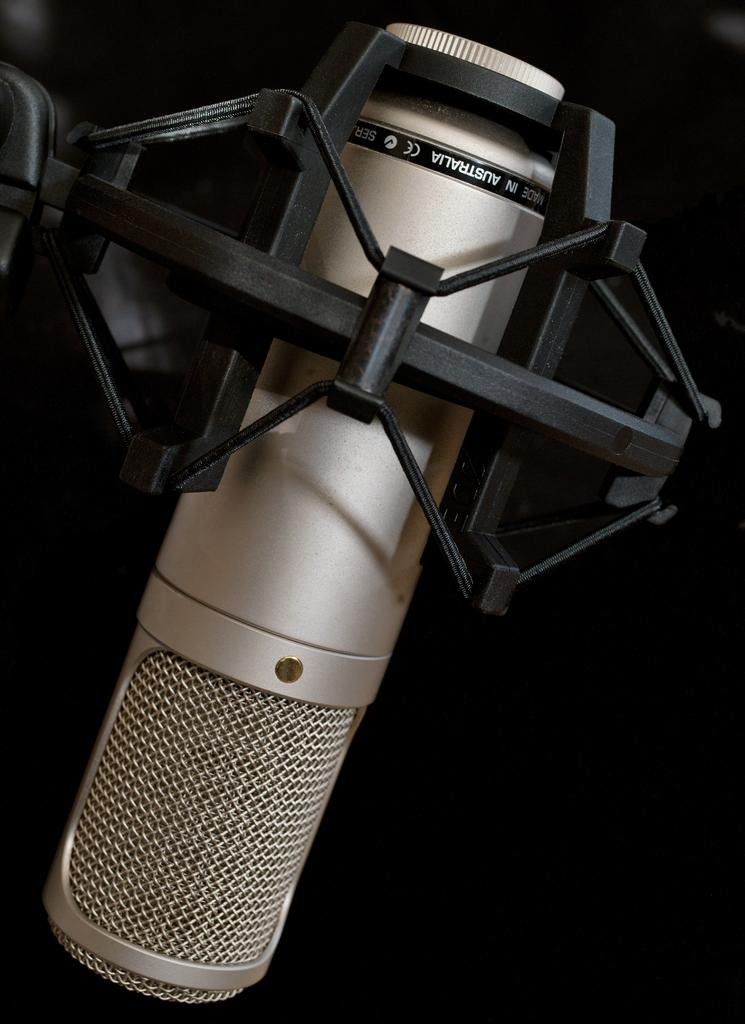What object is the main subject in the image? There is a mic in the image. How is the mic positioned in the image? The mic is mounted to a stand. What type of crime is being committed with the mic in the image? There is no crime being committed with the mic in the image; it is simply a mic mounted to a stand. 